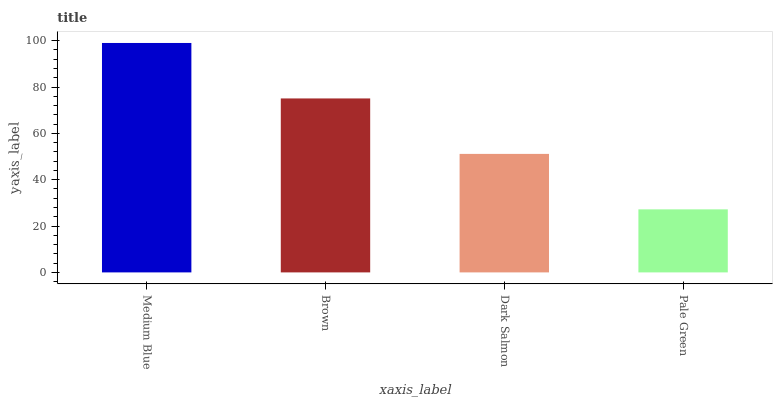Is Pale Green the minimum?
Answer yes or no. Yes. Is Medium Blue the maximum?
Answer yes or no. Yes. Is Brown the minimum?
Answer yes or no. No. Is Brown the maximum?
Answer yes or no. No. Is Medium Blue greater than Brown?
Answer yes or no. Yes. Is Brown less than Medium Blue?
Answer yes or no. Yes. Is Brown greater than Medium Blue?
Answer yes or no. No. Is Medium Blue less than Brown?
Answer yes or no. No. Is Brown the high median?
Answer yes or no. Yes. Is Dark Salmon the low median?
Answer yes or no. Yes. Is Pale Green the high median?
Answer yes or no. No. Is Brown the low median?
Answer yes or no. No. 